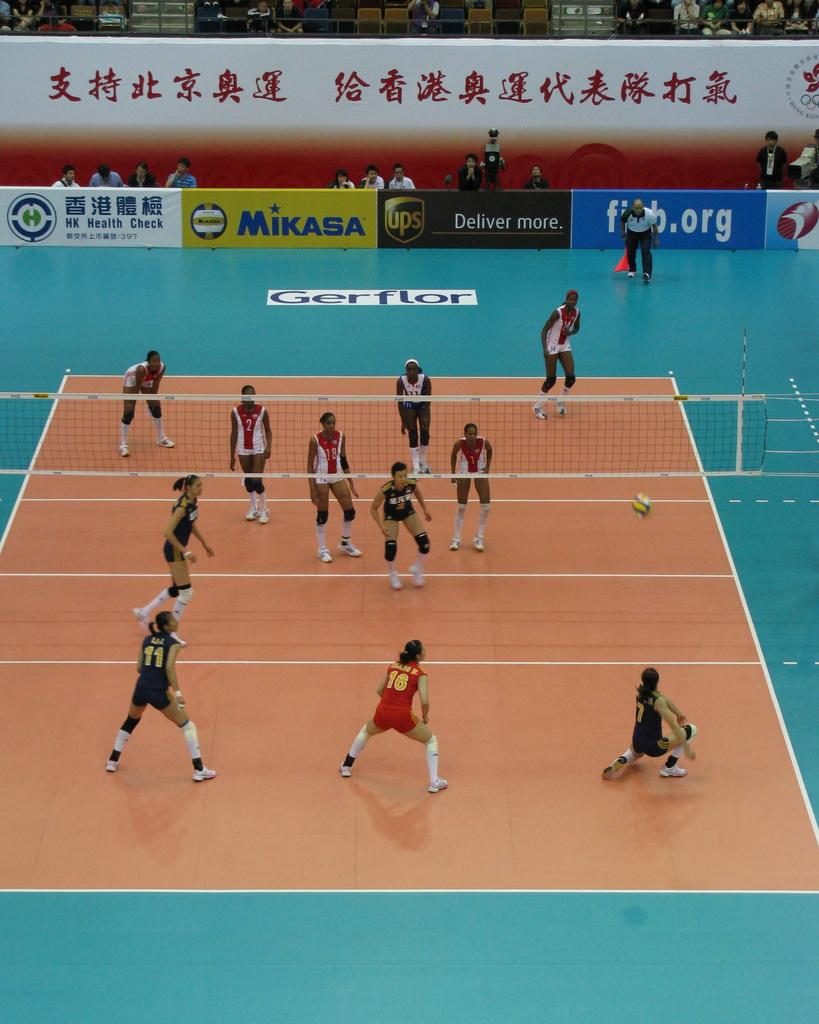<image>
Render a clear and concise summary of the photo. Mikasa and UPS are among the brands advertised at this volleyball game. 